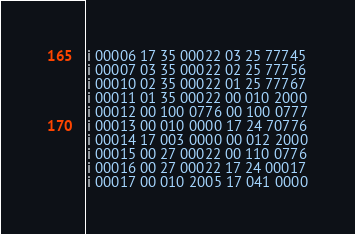<code> <loc_0><loc_0><loc_500><loc_500><_Octave_>i 00006 17 35 00022 03 25 77745
i 00007 03 35 00022 02 25 77756
i 00010 02 35 00022 01 25 77767
i 00011 01 35 00022 00 010 2000
i 00012 00 100 0776 00 100 0777
i 00013 00 010 0000 17 24 70776
i 00014 17 003 0000 00 012 2000
i 00015 00 27 00022 00 110 0776
i 00016 00 27 00022 17 24 00017
i 00017 00 010 2005 17 041 0000</code> 